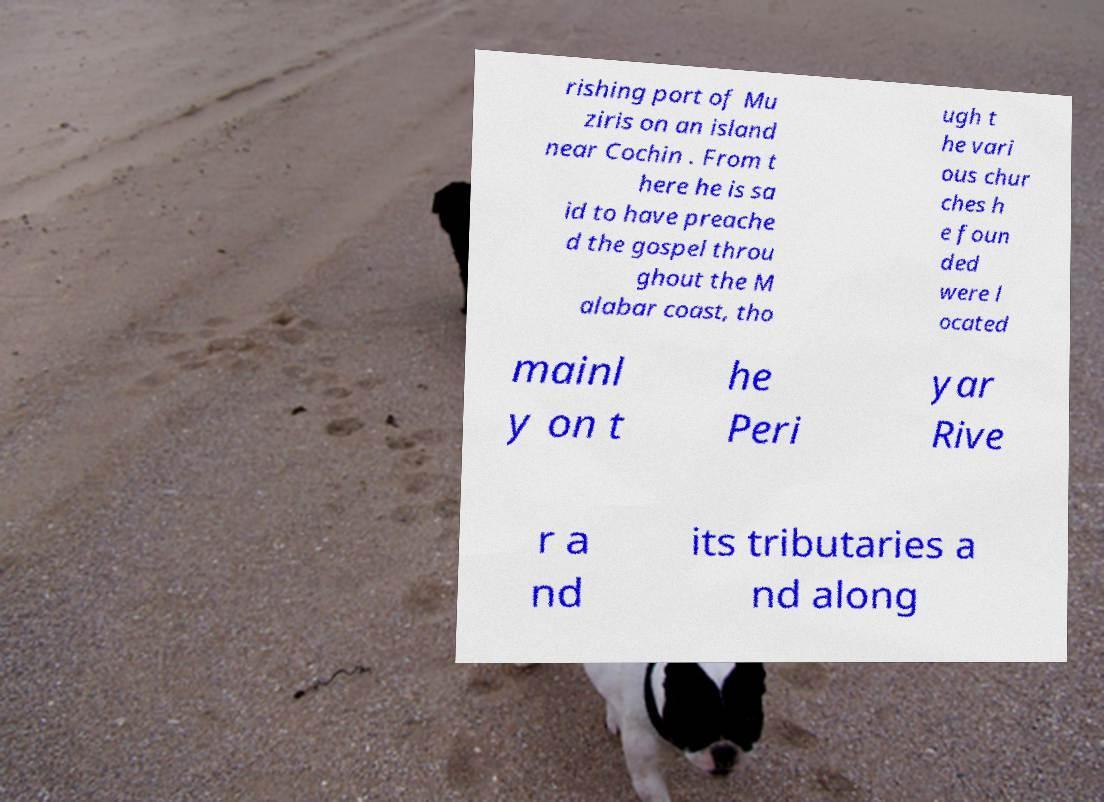Could you assist in decoding the text presented in this image and type it out clearly? rishing port of Mu ziris on an island near Cochin . From t here he is sa id to have preache d the gospel throu ghout the M alabar coast, tho ugh t he vari ous chur ches h e foun ded were l ocated mainl y on t he Peri yar Rive r a nd its tributaries a nd along 